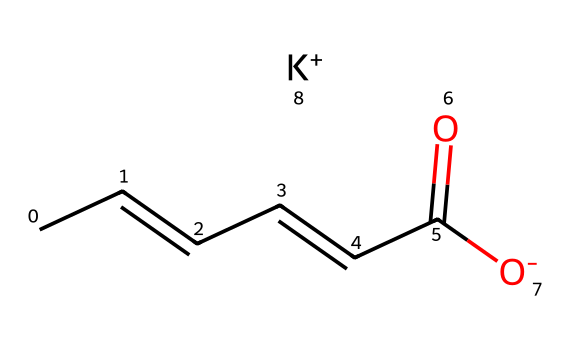What is the molecular formula of potassium sorbate? To determine the molecular formula, we look at the elements in the SMILES. The components are carbon (C), hydrogen (H), oxygen (O), and potassium (K). The six carbon atoms are indicated by "CC=CC=CC(=O)", with the presence of five hydrogen atoms from the alkene structure, one oxygen from the carboxylic group "=O", connected to another oxygen with a potassium ion, yielding C6H7O2K.
Answer: C6H7O2K How many carbon atoms are present in potassium sorbate? In the SMILES representation "CC=CC=CC(=O)", we can count the carbon atoms: there are six carbon atoms in total within this chain.
Answer: 6 What type of bond is indicated by the "CC=CC" portion of the structure? The "CC=CC" part indicates a double bond between the carbon atoms, specifically an alkene functional group which is characterized by carbon-carbon double bonds. Therefore, this structure has at least one double bond present.
Answer: double bond What is the role of the potassium ion (K+) in potassium sorbate? The potassium ion (K+) acts as a counterion, creating a salt with the sorbate ion, which helps in stabilizing the overall structure and enhancing its solubility in food products, providing the preservative effect.
Answer: counterion Is potassium sorbate considered a natural or synthetic preservative? Potassium sorbate is classified as a synthetic preservative, commonly used to inhibit mold and yeast growth in food products. This classification is based on its production methods and usage history.
Answer: synthetic How does the structure of potassium sorbate relate to its preservative properties? The presence of the carboxylate ion (O=C(O−)) allows potassium sorbate to inhibit microbial growth by disrupting their cell membrane integrity, making it effective as a preservative. This connection is between the functional groups and their interaction with microbial cells.
Answer: inhibits microbial growth 